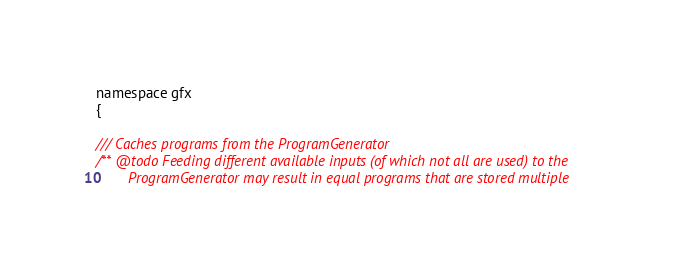Convert code to text. <code><loc_0><loc_0><loc_500><loc_500><_C_>namespace gfx
{

/// Caches programs from the ProgramGenerator
/** @todo Feeding different available inputs (of which not all are used) to the
		ProgramGenerator may result in equal programs that are stored multiple</code> 